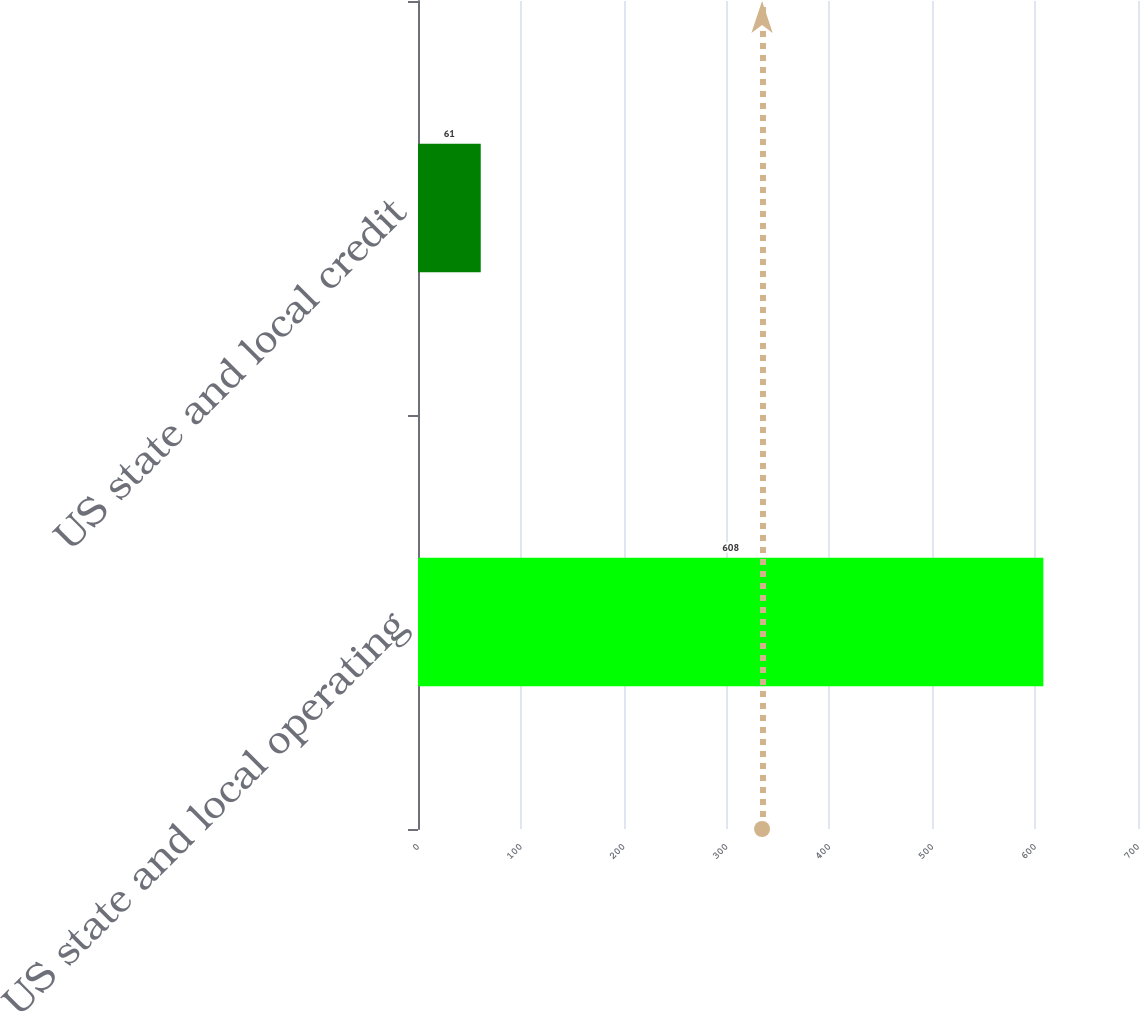<chart> <loc_0><loc_0><loc_500><loc_500><bar_chart><fcel>US state and local operating<fcel>US state and local credit<nl><fcel>608<fcel>61<nl></chart> 